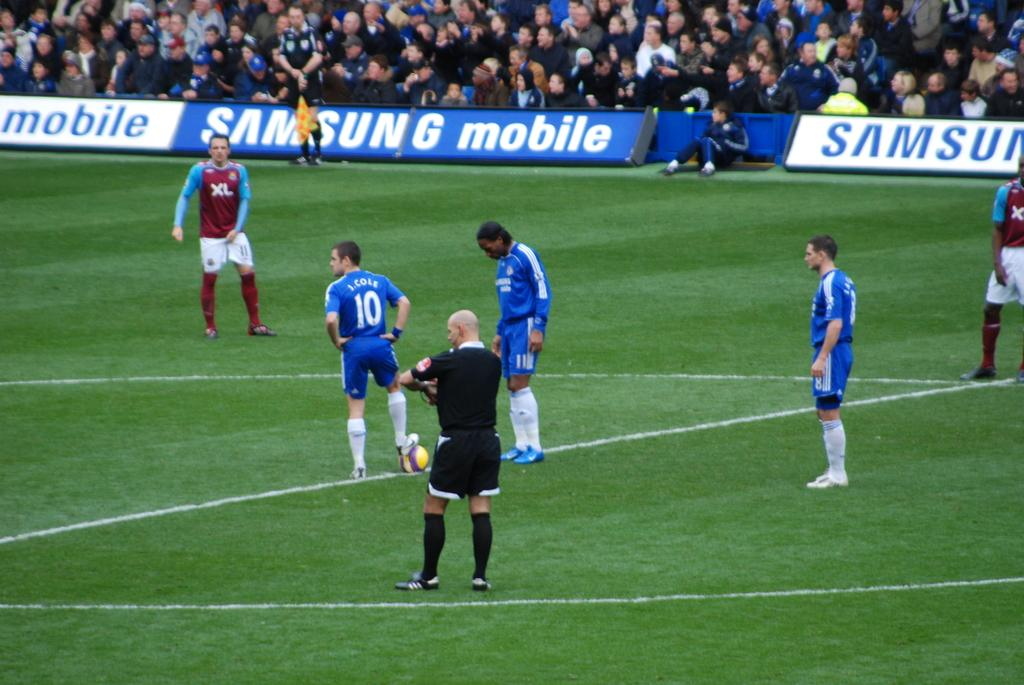Provide a one-sentence caption for the provided image. A group of soccer players are standing on a field with Samsung ads on the sidelines. 